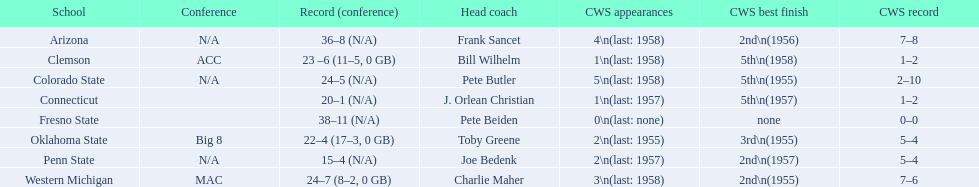What are all the learning establishments? Arizona, Clemson, Colorado State, Connecticut, Fresno State, Oklahoma State, Penn State, Western Michigan. Which involve clemson and western michigan? Clemson, Western Michigan. From these, which has more cws appearances? Western Michigan. 